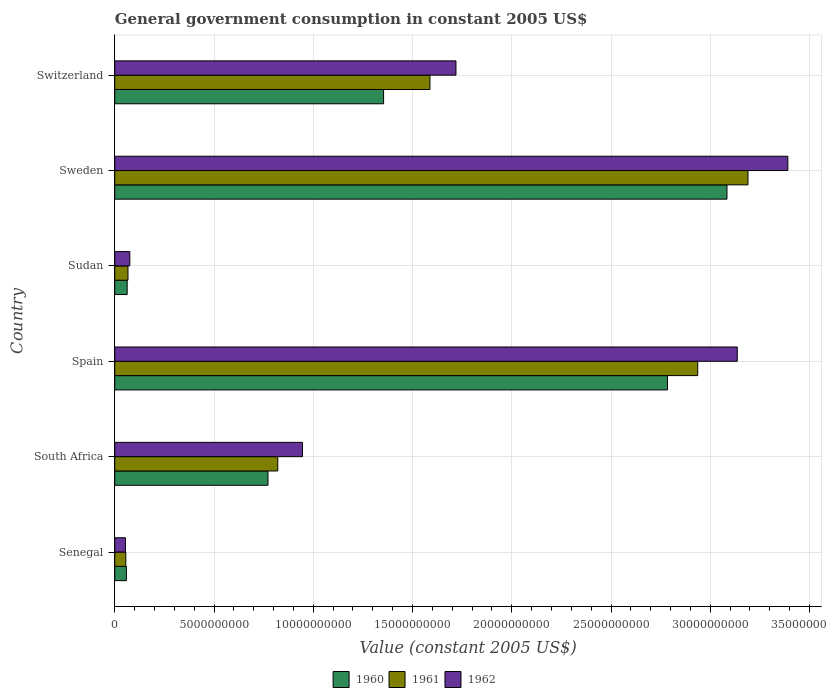How many different coloured bars are there?
Your response must be concise. 3. How many groups of bars are there?
Ensure brevity in your answer.  6. Are the number of bars on each tick of the Y-axis equal?
Your answer should be very brief. Yes. How many bars are there on the 1st tick from the top?
Ensure brevity in your answer.  3. How many bars are there on the 3rd tick from the bottom?
Ensure brevity in your answer.  3. What is the label of the 4th group of bars from the top?
Provide a short and direct response. Spain. In how many cases, is the number of bars for a given country not equal to the number of legend labels?
Make the answer very short. 0. What is the government conusmption in 1961 in Switzerland?
Provide a succinct answer. 1.59e+1. Across all countries, what is the maximum government conusmption in 1961?
Make the answer very short. 3.19e+1. Across all countries, what is the minimum government conusmption in 1960?
Ensure brevity in your answer.  5.86e+08. In which country was the government conusmption in 1962 maximum?
Your response must be concise. Sweden. In which country was the government conusmption in 1960 minimum?
Offer a very short reply. Senegal. What is the total government conusmption in 1962 in the graph?
Offer a terse response. 9.32e+1. What is the difference between the government conusmption in 1961 in Senegal and that in Sweden?
Ensure brevity in your answer.  -3.13e+1. What is the difference between the government conusmption in 1961 in Switzerland and the government conusmption in 1960 in Sweden?
Your response must be concise. -1.50e+1. What is the average government conusmption in 1961 per country?
Offer a terse response. 1.44e+1. What is the difference between the government conusmption in 1960 and government conusmption in 1962 in Switzerland?
Give a very brief answer. -3.64e+09. What is the ratio of the government conusmption in 1961 in South Africa to that in Spain?
Your answer should be very brief. 0.28. What is the difference between the highest and the second highest government conusmption in 1960?
Make the answer very short. 3.00e+09. What is the difference between the highest and the lowest government conusmption in 1961?
Provide a short and direct response. 3.13e+1. Is the sum of the government conusmption in 1962 in Senegal and South Africa greater than the maximum government conusmption in 1960 across all countries?
Your answer should be very brief. No. Are all the bars in the graph horizontal?
Your response must be concise. Yes. What is the difference between two consecutive major ticks on the X-axis?
Your answer should be compact. 5.00e+09. Does the graph contain any zero values?
Offer a terse response. No. Does the graph contain grids?
Your answer should be compact. Yes. Where does the legend appear in the graph?
Offer a terse response. Bottom center. How many legend labels are there?
Provide a succinct answer. 3. What is the title of the graph?
Your answer should be compact. General government consumption in constant 2005 US$. Does "2012" appear as one of the legend labels in the graph?
Ensure brevity in your answer.  No. What is the label or title of the X-axis?
Your response must be concise. Value (constant 2005 US$). What is the Value (constant 2005 US$) in 1960 in Senegal?
Make the answer very short. 5.86e+08. What is the Value (constant 2005 US$) of 1961 in Senegal?
Offer a very short reply. 5.55e+08. What is the Value (constant 2005 US$) of 1962 in Senegal?
Your response must be concise. 5.41e+08. What is the Value (constant 2005 US$) in 1960 in South Africa?
Provide a short and direct response. 7.72e+09. What is the Value (constant 2005 US$) in 1961 in South Africa?
Your response must be concise. 8.21e+09. What is the Value (constant 2005 US$) of 1962 in South Africa?
Offer a terse response. 9.46e+09. What is the Value (constant 2005 US$) in 1960 in Spain?
Keep it short and to the point. 2.78e+1. What is the Value (constant 2005 US$) in 1961 in Spain?
Ensure brevity in your answer.  2.94e+1. What is the Value (constant 2005 US$) of 1962 in Spain?
Keep it short and to the point. 3.14e+1. What is the Value (constant 2005 US$) of 1960 in Sudan?
Offer a very short reply. 6.26e+08. What is the Value (constant 2005 US$) of 1961 in Sudan?
Your response must be concise. 6.66e+08. What is the Value (constant 2005 US$) in 1962 in Sudan?
Your answer should be very brief. 7.58e+08. What is the Value (constant 2005 US$) in 1960 in Sweden?
Provide a succinct answer. 3.08e+1. What is the Value (constant 2005 US$) in 1961 in Sweden?
Give a very brief answer. 3.19e+1. What is the Value (constant 2005 US$) in 1962 in Sweden?
Your response must be concise. 3.39e+1. What is the Value (constant 2005 US$) in 1960 in Switzerland?
Offer a very short reply. 1.35e+1. What is the Value (constant 2005 US$) in 1961 in Switzerland?
Your answer should be compact. 1.59e+1. What is the Value (constant 2005 US$) of 1962 in Switzerland?
Make the answer very short. 1.72e+1. Across all countries, what is the maximum Value (constant 2005 US$) in 1960?
Ensure brevity in your answer.  3.08e+1. Across all countries, what is the maximum Value (constant 2005 US$) in 1961?
Provide a short and direct response. 3.19e+1. Across all countries, what is the maximum Value (constant 2005 US$) of 1962?
Keep it short and to the point. 3.39e+1. Across all countries, what is the minimum Value (constant 2005 US$) in 1960?
Your answer should be very brief. 5.86e+08. Across all countries, what is the minimum Value (constant 2005 US$) of 1961?
Give a very brief answer. 5.55e+08. Across all countries, what is the minimum Value (constant 2005 US$) of 1962?
Provide a succinct answer. 5.41e+08. What is the total Value (constant 2005 US$) of 1960 in the graph?
Your response must be concise. 8.12e+1. What is the total Value (constant 2005 US$) of 1961 in the graph?
Offer a terse response. 8.66e+1. What is the total Value (constant 2005 US$) of 1962 in the graph?
Keep it short and to the point. 9.32e+1. What is the difference between the Value (constant 2005 US$) in 1960 in Senegal and that in South Africa?
Your response must be concise. -7.13e+09. What is the difference between the Value (constant 2005 US$) in 1961 in Senegal and that in South Africa?
Ensure brevity in your answer.  -7.66e+09. What is the difference between the Value (constant 2005 US$) in 1962 in Senegal and that in South Africa?
Your answer should be very brief. -8.92e+09. What is the difference between the Value (constant 2005 US$) in 1960 in Senegal and that in Spain?
Your response must be concise. -2.73e+1. What is the difference between the Value (constant 2005 US$) in 1961 in Senegal and that in Spain?
Keep it short and to the point. -2.88e+1. What is the difference between the Value (constant 2005 US$) of 1962 in Senegal and that in Spain?
Make the answer very short. -3.08e+1. What is the difference between the Value (constant 2005 US$) of 1960 in Senegal and that in Sudan?
Keep it short and to the point. -3.97e+07. What is the difference between the Value (constant 2005 US$) in 1961 in Senegal and that in Sudan?
Ensure brevity in your answer.  -1.11e+08. What is the difference between the Value (constant 2005 US$) in 1962 in Senegal and that in Sudan?
Make the answer very short. -2.17e+08. What is the difference between the Value (constant 2005 US$) of 1960 in Senegal and that in Sweden?
Offer a very short reply. -3.03e+1. What is the difference between the Value (constant 2005 US$) of 1961 in Senegal and that in Sweden?
Make the answer very short. -3.13e+1. What is the difference between the Value (constant 2005 US$) of 1962 in Senegal and that in Sweden?
Offer a very short reply. -3.34e+1. What is the difference between the Value (constant 2005 US$) in 1960 in Senegal and that in Switzerland?
Give a very brief answer. -1.30e+1. What is the difference between the Value (constant 2005 US$) in 1961 in Senegal and that in Switzerland?
Your answer should be very brief. -1.53e+1. What is the difference between the Value (constant 2005 US$) of 1962 in Senegal and that in Switzerland?
Ensure brevity in your answer.  -1.66e+1. What is the difference between the Value (constant 2005 US$) in 1960 in South Africa and that in Spain?
Offer a terse response. -2.01e+1. What is the difference between the Value (constant 2005 US$) in 1961 in South Africa and that in Spain?
Offer a terse response. -2.12e+1. What is the difference between the Value (constant 2005 US$) of 1962 in South Africa and that in Spain?
Offer a very short reply. -2.19e+1. What is the difference between the Value (constant 2005 US$) of 1960 in South Africa and that in Sudan?
Your answer should be compact. 7.09e+09. What is the difference between the Value (constant 2005 US$) in 1961 in South Africa and that in Sudan?
Your answer should be very brief. 7.55e+09. What is the difference between the Value (constant 2005 US$) of 1962 in South Africa and that in Sudan?
Provide a succinct answer. 8.70e+09. What is the difference between the Value (constant 2005 US$) of 1960 in South Africa and that in Sweden?
Make the answer very short. -2.31e+1. What is the difference between the Value (constant 2005 US$) in 1961 in South Africa and that in Sweden?
Offer a very short reply. -2.37e+1. What is the difference between the Value (constant 2005 US$) in 1962 in South Africa and that in Sweden?
Keep it short and to the point. -2.45e+1. What is the difference between the Value (constant 2005 US$) in 1960 in South Africa and that in Switzerland?
Offer a terse response. -5.82e+09. What is the difference between the Value (constant 2005 US$) in 1961 in South Africa and that in Switzerland?
Your response must be concise. -7.67e+09. What is the difference between the Value (constant 2005 US$) of 1962 in South Africa and that in Switzerland?
Your answer should be very brief. -7.73e+09. What is the difference between the Value (constant 2005 US$) in 1960 in Spain and that in Sudan?
Make the answer very short. 2.72e+1. What is the difference between the Value (constant 2005 US$) in 1961 in Spain and that in Sudan?
Your answer should be very brief. 2.87e+1. What is the difference between the Value (constant 2005 US$) of 1962 in Spain and that in Sudan?
Your answer should be very brief. 3.06e+1. What is the difference between the Value (constant 2005 US$) of 1960 in Spain and that in Sweden?
Make the answer very short. -3.00e+09. What is the difference between the Value (constant 2005 US$) of 1961 in Spain and that in Sweden?
Your answer should be very brief. -2.53e+09. What is the difference between the Value (constant 2005 US$) in 1962 in Spain and that in Sweden?
Provide a succinct answer. -2.55e+09. What is the difference between the Value (constant 2005 US$) in 1960 in Spain and that in Switzerland?
Offer a very short reply. 1.43e+1. What is the difference between the Value (constant 2005 US$) of 1961 in Spain and that in Switzerland?
Your response must be concise. 1.35e+1. What is the difference between the Value (constant 2005 US$) of 1962 in Spain and that in Switzerland?
Your answer should be very brief. 1.42e+1. What is the difference between the Value (constant 2005 US$) in 1960 in Sudan and that in Sweden?
Provide a succinct answer. -3.02e+1. What is the difference between the Value (constant 2005 US$) in 1961 in Sudan and that in Sweden?
Keep it short and to the point. -3.12e+1. What is the difference between the Value (constant 2005 US$) of 1962 in Sudan and that in Sweden?
Your response must be concise. -3.31e+1. What is the difference between the Value (constant 2005 US$) in 1960 in Sudan and that in Switzerland?
Ensure brevity in your answer.  -1.29e+1. What is the difference between the Value (constant 2005 US$) in 1961 in Sudan and that in Switzerland?
Provide a short and direct response. -1.52e+1. What is the difference between the Value (constant 2005 US$) in 1962 in Sudan and that in Switzerland?
Your answer should be compact. -1.64e+1. What is the difference between the Value (constant 2005 US$) of 1960 in Sweden and that in Switzerland?
Offer a terse response. 1.73e+1. What is the difference between the Value (constant 2005 US$) in 1961 in Sweden and that in Switzerland?
Give a very brief answer. 1.60e+1. What is the difference between the Value (constant 2005 US$) in 1962 in Sweden and that in Switzerland?
Provide a succinct answer. 1.67e+1. What is the difference between the Value (constant 2005 US$) of 1960 in Senegal and the Value (constant 2005 US$) of 1961 in South Africa?
Your answer should be compact. -7.63e+09. What is the difference between the Value (constant 2005 US$) in 1960 in Senegal and the Value (constant 2005 US$) in 1962 in South Africa?
Keep it short and to the point. -8.87e+09. What is the difference between the Value (constant 2005 US$) in 1961 in Senegal and the Value (constant 2005 US$) in 1962 in South Africa?
Offer a very short reply. -8.90e+09. What is the difference between the Value (constant 2005 US$) of 1960 in Senegal and the Value (constant 2005 US$) of 1961 in Spain?
Ensure brevity in your answer.  -2.88e+1. What is the difference between the Value (constant 2005 US$) of 1960 in Senegal and the Value (constant 2005 US$) of 1962 in Spain?
Your response must be concise. -3.08e+1. What is the difference between the Value (constant 2005 US$) in 1961 in Senegal and the Value (constant 2005 US$) in 1962 in Spain?
Keep it short and to the point. -3.08e+1. What is the difference between the Value (constant 2005 US$) of 1960 in Senegal and the Value (constant 2005 US$) of 1961 in Sudan?
Offer a very short reply. -8.05e+07. What is the difference between the Value (constant 2005 US$) of 1960 in Senegal and the Value (constant 2005 US$) of 1962 in Sudan?
Make the answer very short. -1.72e+08. What is the difference between the Value (constant 2005 US$) in 1961 in Senegal and the Value (constant 2005 US$) in 1962 in Sudan?
Your answer should be compact. -2.03e+08. What is the difference between the Value (constant 2005 US$) in 1960 in Senegal and the Value (constant 2005 US$) in 1961 in Sweden?
Your response must be concise. -3.13e+1. What is the difference between the Value (constant 2005 US$) of 1960 in Senegal and the Value (constant 2005 US$) of 1962 in Sweden?
Offer a very short reply. -3.33e+1. What is the difference between the Value (constant 2005 US$) in 1961 in Senegal and the Value (constant 2005 US$) in 1962 in Sweden?
Keep it short and to the point. -3.34e+1. What is the difference between the Value (constant 2005 US$) of 1960 in Senegal and the Value (constant 2005 US$) of 1961 in Switzerland?
Offer a very short reply. -1.53e+1. What is the difference between the Value (constant 2005 US$) in 1960 in Senegal and the Value (constant 2005 US$) in 1962 in Switzerland?
Ensure brevity in your answer.  -1.66e+1. What is the difference between the Value (constant 2005 US$) in 1961 in Senegal and the Value (constant 2005 US$) in 1962 in Switzerland?
Offer a terse response. -1.66e+1. What is the difference between the Value (constant 2005 US$) in 1960 in South Africa and the Value (constant 2005 US$) in 1961 in Spain?
Your answer should be very brief. -2.16e+1. What is the difference between the Value (constant 2005 US$) in 1960 in South Africa and the Value (constant 2005 US$) in 1962 in Spain?
Your answer should be very brief. -2.36e+1. What is the difference between the Value (constant 2005 US$) of 1961 in South Africa and the Value (constant 2005 US$) of 1962 in Spain?
Provide a succinct answer. -2.31e+1. What is the difference between the Value (constant 2005 US$) of 1960 in South Africa and the Value (constant 2005 US$) of 1961 in Sudan?
Your response must be concise. 7.05e+09. What is the difference between the Value (constant 2005 US$) of 1960 in South Africa and the Value (constant 2005 US$) of 1962 in Sudan?
Give a very brief answer. 6.96e+09. What is the difference between the Value (constant 2005 US$) in 1961 in South Africa and the Value (constant 2005 US$) in 1962 in Sudan?
Make the answer very short. 7.45e+09. What is the difference between the Value (constant 2005 US$) of 1960 in South Africa and the Value (constant 2005 US$) of 1961 in Sweden?
Give a very brief answer. -2.42e+1. What is the difference between the Value (constant 2005 US$) of 1960 in South Africa and the Value (constant 2005 US$) of 1962 in Sweden?
Offer a terse response. -2.62e+1. What is the difference between the Value (constant 2005 US$) in 1961 in South Africa and the Value (constant 2005 US$) in 1962 in Sweden?
Keep it short and to the point. -2.57e+1. What is the difference between the Value (constant 2005 US$) in 1960 in South Africa and the Value (constant 2005 US$) in 1961 in Switzerland?
Provide a short and direct response. -8.16e+09. What is the difference between the Value (constant 2005 US$) of 1960 in South Africa and the Value (constant 2005 US$) of 1962 in Switzerland?
Make the answer very short. -9.47e+09. What is the difference between the Value (constant 2005 US$) of 1961 in South Africa and the Value (constant 2005 US$) of 1962 in Switzerland?
Give a very brief answer. -8.98e+09. What is the difference between the Value (constant 2005 US$) in 1960 in Spain and the Value (constant 2005 US$) in 1961 in Sudan?
Your answer should be compact. 2.72e+1. What is the difference between the Value (constant 2005 US$) in 1960 in Spain and the Value (constant 2005 US$) in 1962 in Sudan?
Provide a short and direct response. 2.71e+1. What is the difference between the Value (constant 2005 US$) of 1961 in Spain and the Value (constant 2005 US$) of 1962 in Sudan?
Your answer should be very brief. 2.86e+1. What is the difference between the Value (constant 2005 US$) in 1960 in Spain and the Value (constant 2005 US$) in 1961 in Sweden?
Offer a terse response. -4.05e+09. What is the difference between the Value (constant 2005 US$) in 1960 in Spain and the Value (constant 2005 US$) in 1962 in Sweden?
Provide a succinct answer. -6.06e+09. What is the difference between the Value (constant 2005 US$) in 1961 in Spain and the Value (constant 2005 US$) in 1962 in Sweden?
Keep it short and to the point. -4.54e+09. What is the difference between the Value (constant 2005 US$) in 1960 in Spain and the Value (constant 2005 US$) in 1961 in Switzerland?
Your answer should be compact. 1.20e+1. What is the difference between the Value (constant 2005 US$) of 1960 in Spain and the Value (constant 2005 US$) of 1962 in Switzerland?
Your answer should be very brief. 1.07e+1. What is the difference between the Value (constant 2005 US$) of 1961 in Spain and the Value (constant 2005 US$) of 1962 in Switzerland?
Provide a succinct answer. 1.22e+1. What is the difference between the Value (constant 2005 US$) in 1960 in Sudan and the Value (constant 2005 US$) in 1961 in Sweden?
Your answer should be very brief. -3.13e+1. What is the difference between the Value (constant 2005 US$) in 1960 in Sudan and the Value (constant 2005 US$) in 1962 in Sweden?
Provide a succinct answer. -3.33e+1. What is the difference between the Value (constant 2005 US$) of 1961 in Sudan and the Value (constant 2005 US$) of 1962 in Sweden?
Provide a short and direct response. -3.32e+1. What is the difference between the Value (constant 2005 US$) of 1960 in Sudan and the Value (constant 2005 US$) of 1961 in Switzerland?
Your answer should be very brief. -1.53e+1. What is the difference between the Value (constant 2005 US$) of 1960 in Sudan and the Value (constant 2005 US$) of 1962 in Switzerland?
Give a very brief answer. -1.66e+1. What is the difference between the Value (constant 2005 US$) of 1961 in Sudan and the Value (constant 2005 US$) of 1962 in Switzerland?
Give a very brief answer. -1.65e+1. What is the difference between the Value (constant 2005 US$) in 1960 in Sweden and the Value (constant 2005 US$) in 1961 in Switzerland?
Offer a very short reply. 1.50e+1. What is the difference between the Value (constant 2005 US$) in 1960 in Sweden and the Value (constant 2005 US$) in 1962 in Switzerland?
Make the answer very short. 1.37e+1. What is the difference between the Value (constant 2005 US$) of 1961 in Sweden and the Value (constant 2005 US$) of 1962 in Switzerland?
Make the answer very short. 1.47e+1. What is the average Value (constant 2005 US$) in 1960 per country?
Provide a short and direct response. 1.35e+1. What is the average Value (constant 2005 US$) in 1961 per country?
Keep it short and to the point. 1.44e+1. What is the average Value (constant 2005 US$) of 1962 per country?
Your answer should be very brief. 1.55e+1. What is the difference between the Value (constant 2005 US$) in 1960 and Value (constant 2005 US$) in 1961 in Senegal?
Offer a terse response. 3.05e+07. What is the difference between the Value (constant 2005 US$) in 1960 and Value (constant 2005 US$) in 1962 in Senegal?
Provide a succinct answer. 4.51e+07. What is the difference between the Value (constant 2005 US$) of 1961 and Value (constant 2005 US$) of 1962 in Senegal?
Offer a very short reply. 1.45e+07. What is the difference between the Value (constant 2005 US$) of 1960 and Value (constant 2005 US$) of 1961 in South Africa?
Offer a terse response. -4.93e+08. What is the difference between the Value (constant 2005 US$) in 1960 and Value (constant 2005 US$) in 1962 in South Africa?
Provide a succinct answer. -1.74e+09. What is the difference between the Value (constant 2005 US$) in 1961 and Value (constant 2005 US$) in 1962 in South Africa?
Make the answer very short. -1.25e+09. What is the difference between the Value (constant 2005 US$) in 1960 and Value (constant 2005 US$) in 1961 in Spain?
Provide a succinct answer. -1.52e+09. What is the difference between the Value (constant 2005 US$) of 1960 and Value (constant 2005 US$) of 1962 in Spain?
Offer a very short reply. -3.51e+09. What is the difference between the Value (constant 2005 US$) of 1961 and Value (constant 2005 US$) of 1962 in Spain?
Offer a terse response. -1.99e+09. What is the difference between the Value (constant 2005 US$) of 1960 and Value (constant 2005 US$) of 1961 in Sudan?
Provide a short and direct response. -4.08e+07. What is the difference between the Value (constant 2005 US$) in 1960 and Value (constant 2005 US$) in 1962 in Sudan?
Make the answer very short. -1.33e+08. What is the difference between the Value (constant 2005 US$) of 1961 and Value (constant 2005 US$) of 1962 in Sudan?
Your answer should be very brief. -9.18e+07. What is the difference between the Value (constant 2005 US$) in 1960 and Value (constant 2005 US$) in 1961 in Sweden?
Give a very brief answer. -1.06e+09. What is the difference between the Value (constant 2005 US$) in 1960 and Value (constant 2005 US$) in 1962 in Sweden?
Your response must be concise. -3.07e+09. What is the difference between the Value (constant 2005 US$) in 1961 and Value (constant 2005 US$) in 1962 in Sweden?
Your response must be concise. -2.01e+09. What is the difference between the Value (constant 2005 US$) of 1960 and Value (constant 2005 US$) of 1961 in Switzerland?
Make the answer very short. -2.33e+09. What is the difference between the Value (constant 2005 US$) of 1960 and Value (constant 2005 US$) of 1962 in Switzerland?
Your answer should be compact. -3.64e+09. What is the difference between the Value (constant 2005 US$) in 1961 and Value (constant 2005 US$) in 1962 in Switzerland?
Your response must be concise. -1.31e+09. What is the ratio of the Value (constant 2005 US$) in 1960 in Senegal to that in South Africa?
Give a very brief answer. 0.08. What is the ratio of the Value (constant 2005 US$) in 1961 in Senegal to that in South Africa?
Keep it short and to the point. 0.07. What is the ratio of the Value (constant 2005 US$) in 1962 in Senegal to that in South Africa?
Provide a succinct answer. 0.06. What is the ratio of the Value (constant 2005 US$) of 1960 in Senegal to that in Spain?
Keep it short and to the point. 0.02. What is the ratio of the Value (constant 2005 US$) of 1961 in Senegal to that in Spain?
Provide a short and direct response. 0.02. What is the ratio of the Value (constant 2005 US$) in 1962 in Senegal to that in Spain?
Make the answer very short. 0.02. What is the ratio of the Value (constant 2005 US$) of 1960 in Senegal to that in Sudan?
Provide a succinct answer. 0.94. What is the ratio of the Value (constant 2005 US$) of 1961 in Senegal to that in Sudan?
Your answer should be compact. 0.83. What is the ratio of the Value (constant 2005 US$) of 1962 in Senegal to that in Sudan?
Your answer should be compact. 0.71. What is the ratio of the Value (constant 2005 US$) in 1960 in Senegal to that in Sweden?
Your response must be concise. 0.02. What is the ratio of the Value (constant 2005 US$) of 1961 in Senegal to that in Sweden?
Make the answer very short. 0.02. What is the ratio of the Value (constant 2005 US$) in 1962 in Senegal to that in Sweden?
Make the answer very short. 0.02. What is the ratio of the Value (constant 2005 US$) of 1960 in Senegal to that in Switzerland?
Provide a succinct answer. 0.04. What is the ratio of the Value (constant 2005 US$) in 1961 in Senegal to that in Switzerland?
Give a very brief answer. 0.04. What is the ratio of the Value (constant 2005 US$) of 1962 in Senegal to that in Switzerland?
Provide a succinct answer. 0.03. What is the ratio of the Value (constant 2005 US$) of 1960 in South Africa to that in Spain?
Give a very brief answer. 0.28. What is the ratio of the Value (constant 2005 US$) of 1961 in South Africa to that in Spain?
Ensure brevity in your answer.  0.28. What is the ratio of the Value (constant 2005 US$) of 1962 in South Africa to that in Spain?
Your answer should be compact. 0.3. What is the ratio of the Value (constant 2005 US$) in 1960 in South Africa to that in Sudan?
Your answer should be compact. 12.34. What is the ratio of the Value (constant 2005 US$) of 1961 in South Africa to that in Sudan?
Provide a succinct answer. 12.32. What is the ratio of the Value (constant 2005 US$) of 1962 in South Africa to that in Sudan?
Make the answer very short. 12.47. What is the ratio of the Value (constant 2005 US$) of 1960 in South Africa to that in Sweden?
Give a very brief answer. 0.25. What is the ratio of the Value (constant 2005 US$) in 1961 in South Africa to that in Sweden?
Keep it short and to the point. 0.26. What is the ratio of the Value (constant 2005 US$) of 1962 in South Africa to that in Sweden?
Provide a succinct answer. 0.28. What is the ratio of the Value (constant 2005 US$) of 1960 in South Africa to that in Switzerland?
Offer a very short reply. 0.57. What is the ratio of the Value (constant 2005 US$) of 1961 in South Africa to that in Switzerland?
Your answer should be very brief. 0.52. What is the ratio of the Value (constant 2005 US$) of 1962 in South Africa to that in Switzerland?
Your answer should be very brief. 0.55. What is the ratio of the Value (constant 2005 US$) in 1960 in Spain to that in Sudan?
Your answer should be compact. 44.51. What is the ratio of the Value (constant 2005 US$) of 1961 in Spain to that in Sudan?
Provide a succinct answer. 44.07. What is the ratio of the Value (constant 2005 US$) of 1962 in Spain to that in Sudan?
Give a very brief answer. 41.36. What is the ratio of the Value (constant 2005 US$) in 1960 in Spain to that in Sweden?
Offer a very short reply. 0.9. What is the ratio of the Value (constant 2005 US$) in 1961 in Spain to that in Sweden?
Your response must be concise. 0.92. What is the ratio of the Value (constant 2005 US$) of 1962 in Spain to that in Sweden?
Your answer should be compact. 0.92. What is the ratio of the Value (constant 2005 US$) in 1960 in Spain to that in Switzerland?
Ensure brevity in your answer.  2.06. What is the ratio of the Value (constant 2005 US$) in 1961 in Spain to that in Switzerland?
Your response must be concise. 1.85. What is the ratio of the Value (constant 2005 US$) in 1962 in Spain to that in Switzerland?
Give a very brief answer. 1.82. What is the ratio of the Value (constant 2005 US$) of 1960 in Sudan to that in Sweden?
Your answer should be very brief. 0.02. What is the ratio of the Value (constant 2005 US$) of 1961 in Sudan to that in Sweden?
Your response must be concise. 0.02. What is the ratio of the Value (constant 2005 US$) of 1962 in Sudan to that in Sweden?
Ensure brevity in your answer.  0.02. What is the ratio of the Value (constant 2005 US$) in 1960 in Sudan to that in Switzerland?
Your answer should be very brief. 0.05. What is the ratio of the Value (constant 2005 US$) in 1961 in Sudan to that in Switzerland?
Offer a very short reply. 0.04. What is the ratio of the Value (constant 2005 US$) of 1962 in Sudan to that in Switzerland?
Give a very brief answer. 0.04. What is the ratio of the Value (constant 2005 US$) in 1960 in Sweden to that in Switzerland?
Your response must be concise. 2.28. What is the ratio of the Value (constant 2005 US$) of 1961 in Sweden to that in Switzerland?
Your response must be concise. 2.01. What is the ratio of the Value (constant 2005 US$) of 1962 in Sweden to that in Switzerland?
Ensure brevity in your answer.  1.97. What is the difference between the highest and the second highest Value (constant 2005 US$) in 1960?
Provide a short and direct response. 3.00e+09. What is the difference between the highest and the second highest Value (constant 2005 US$) in 1961?
Keep it short and to the point. 2.53e+09. What is the difference between the highest and the second highest Value (constant 2005 US$) in 1962?
Your answer should be very brief. 2.55e+09. What is the difference between the highest and the lowest Value (constant 2005 US$) of 1960?
Keep it short and to the point. 3.03e+1. What is the difference between the highest and the lowest Value (constant 2005 US$) of 1961?
Provide a succinct answer. 3.13e+1. What is the difference between the highest and the lowest Value (constant 2005 US$) of 1962?
Offer a very short reply. 3.34e+1. 